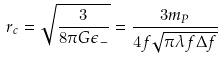Convert formula to latex. <formula><loc_0><loc_0><loc_500><loc_500>r _ { c } = \sqrt { \frac { 3 } { 8 \pi G \epsilon _ { - } } } = \frac { 3 m _ { P } } { 4 f \sqrt { \pi \lambda f \Delta f } }</formula> 